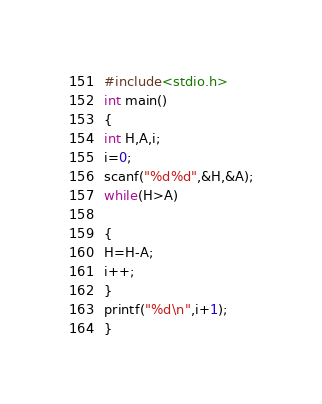Convert code to text. <code><loc_0><loc_0><loc_500><loc_500><_C_>#include<stdio.h>
int main()
{
int H,A,i;
i=0;
scanf("%d%d",&H,&A);
while(H>A)

{
H=H-A;
i++;
}
printf("%d\n",i+1);
}</code> 